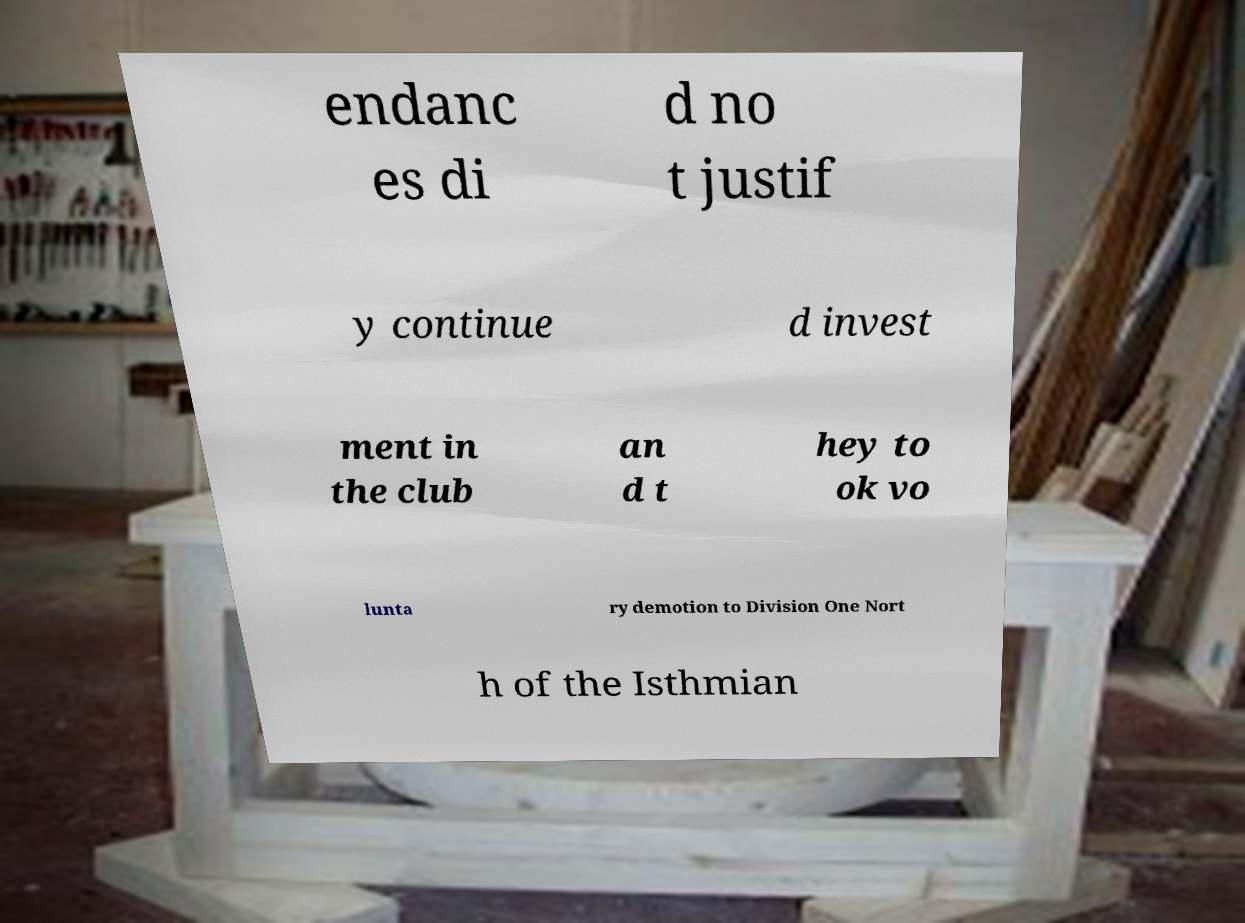Can you accurately transcribe the text from the provided image for me? endanc es di d no t justif y continue d invest ment in the club an d t hey to ok vo lunta ry demotion to Division One Nort h of the Isthmian 